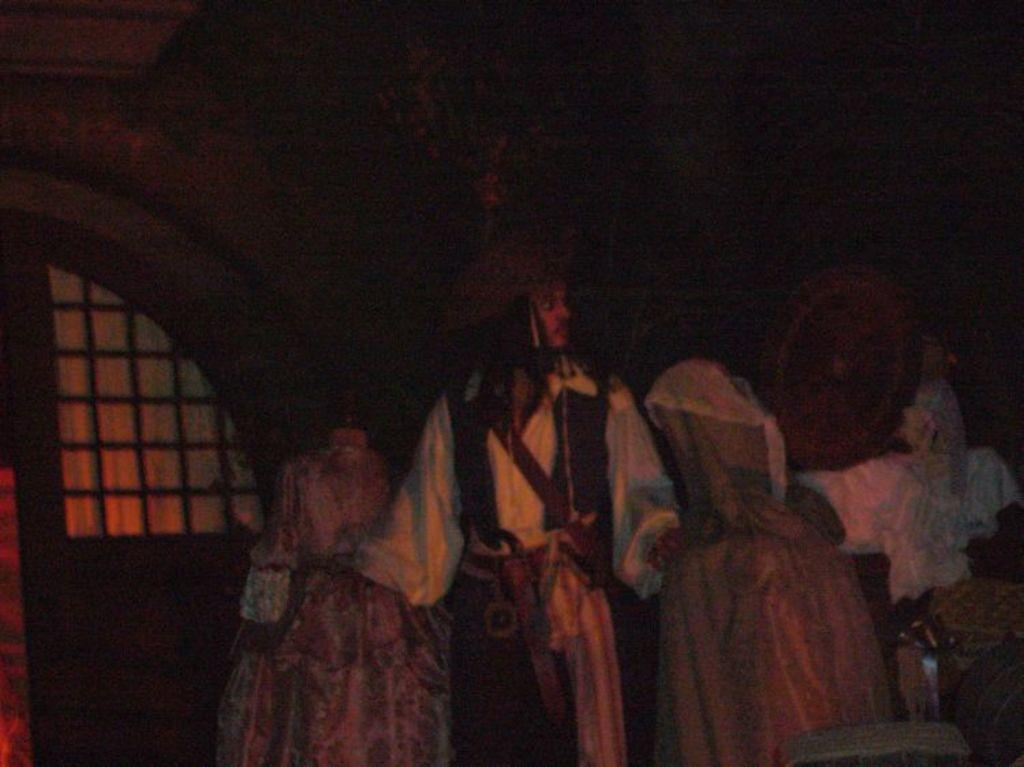What is the main subject of the image? There is a person standing in the image. What is the person wearing in the image? The person is wearing a costume. What else can be seen in the image besides the person? There are clothes visible in the image. Where is the glass located in the image? The glass is on the left side of the image. What type of railway can be seen in the image? There is no railway present in the image. Is the person wearing a scarf in the image? The provided facts do not mention a scarf, so we cannot determine if the person is wearing one. 